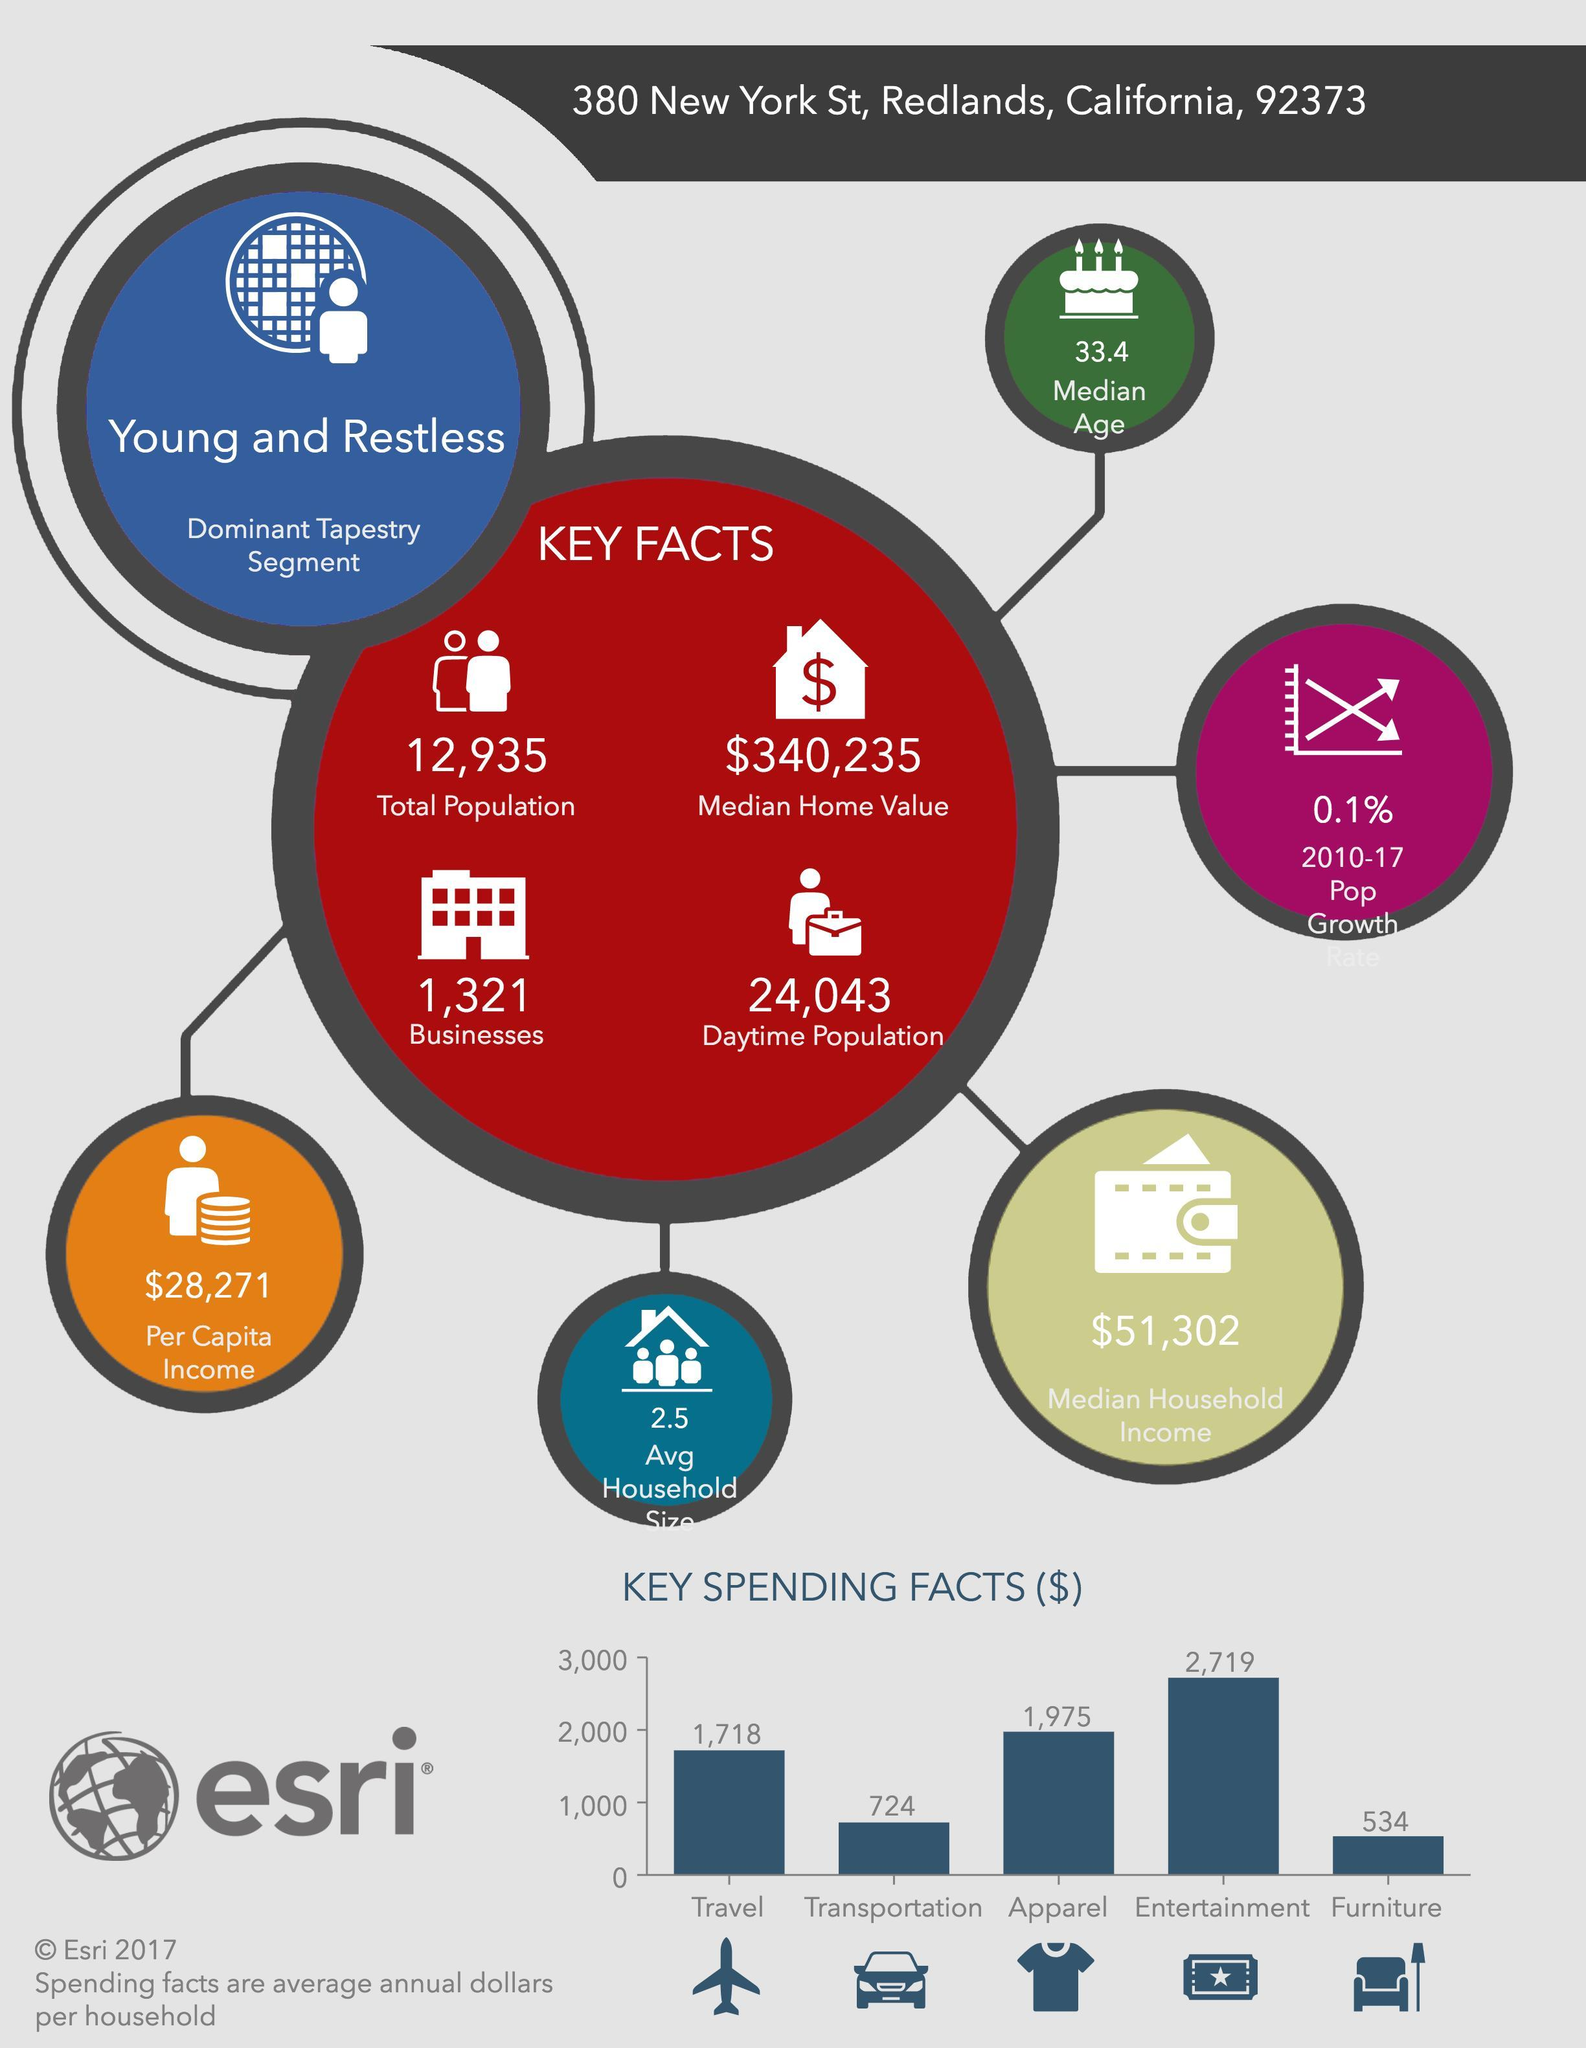Which is the transportation vehicle shown in the infographic- bus, cycle, car, train?
Answer the question with a short phrase. car For which item New York spends second highest amount of cash in dollars? Apparel Which is the apparel shown in the infographic- Trousers, shirt, T-shirt, jeans? T-shirt For which item New York spends second least amount of cash? Transportation How much crowded is the New York in the daytime? 24,043 What is the per Capita Income of New York? $28,271 How much dollars New York spend for both travel and transportation? 2,442 For which all categories New York spend more than 1000 dollars? Travel, Apparel, Entertainment What is the average household size in New York? 2.5 For how many items New York spend more than 2,000 dollars? 1 